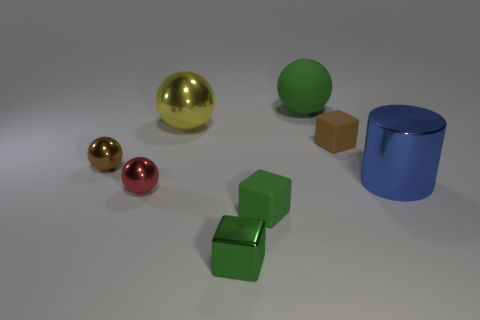Subtract all brown rubber cubes. How many cubes are left? 2 Add 2 shiny balls. How many objects exist? 10 Subtract 1 cylinders. How many cylinders are left? 0 Subtract all brown spheres. How many spheres are left? 3 Subtract 1 red balls. How many objects are left? 7 Subtract all cylinders. How many objects are left? 7 Subtract all red spheres. Subtract all purple blocks. How many spheres are left? 3 Subtract all blue cubes. How many green cylinders are left? 0 Subtract all large metal cubes. Subtract all small shiny spheres. How many objects are left? 6 Add 4 large shiny spheres. How many large shiny spheres are left? 5 